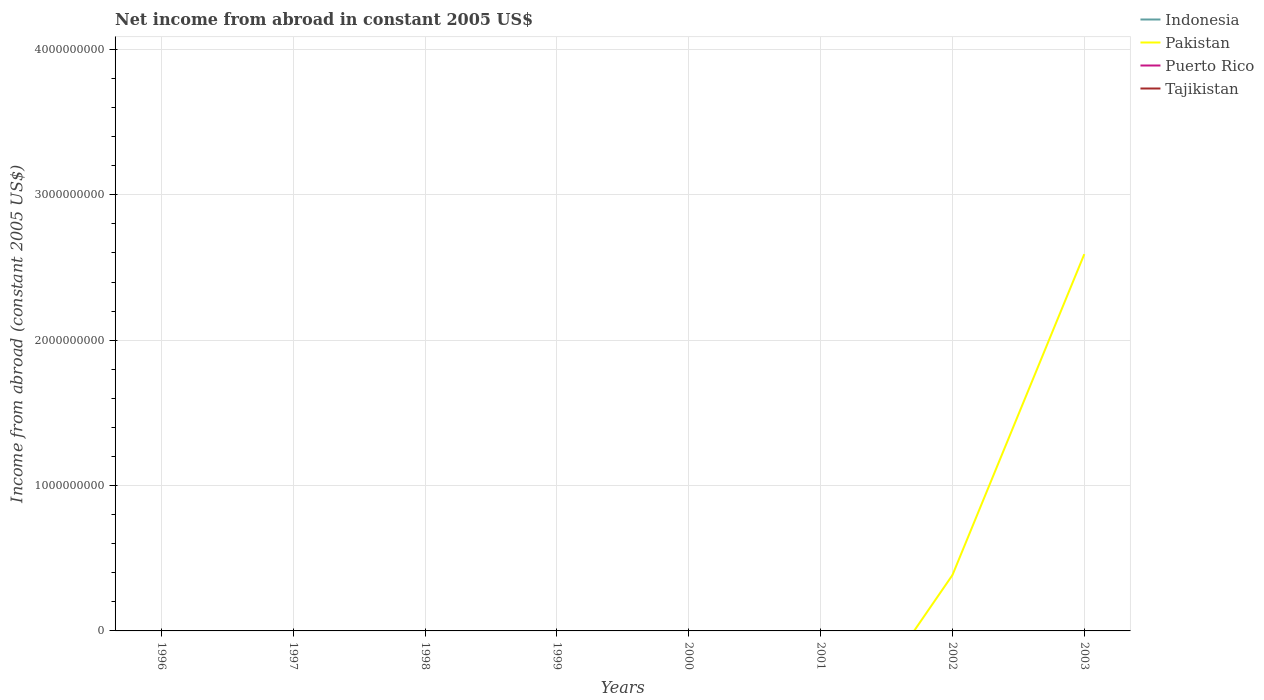Does the line corresponding to Tajikistan intersect with the line corresponding to Indonesia?
Provide a short and direct response. No. Across all years, what is the maximum net income from abroad in Puerto Rico?
Your answer should be very brief. 0. What is the difference between the highest and the second highest net income from abroad in Pakistan?
Your response must be concise. 2.59e+09. What is the difference between the highest and the lowest net income from abroad in Tajikistan?
Your answer should be compact. 0. Is the net income from abroad in Tajikistan strictly greater than the net income from abroad in Puerto Rico over the years?
Ensure brevity in your answer.  No. How many years are there in the graph?
Provide a short and direct response. 8. What is the difference between two consecutive major ticks on the Y-axis?
Offer a terse response. 1.00e+09. Does the graph contain grids?
Provide a succinct answer. Yes. Where does the legend appear in the graph?
Provide a short and direct response. Top right. How many legend labels are there?
Give a very brief answer. 4. How are the legend labels stacked?
Your answer should be compact. Vertical. What is the title of the graph?
Keep it short and to the point. Net income from abroad in constant 2005 US$. Does "Marshall Islands" appear as one of the legend labels in the graph?
Ensure brevity in your answer.  No. What is the label or title of the X-axis?
Make the answer very short. Years. What is the label or title of the Y-axis?
Offer a terse response. Income from abroad (constant 2005 US$). What is the Income from abroad (constant 2005 US$) of Pakistan in 1996?
Provide a short and direct response. 0. What is the Income from abroad (constant 2005 US$) of Tajikistan in 1996?
Offer a terse response. 0. What is the Income from abroad (constant 2005 US$) of Pakistan in 1997?
Your answer should be very brief. 0. What is the Income from abroad (constant 2005 US$) in Puerto Rico in 1997?
Your response must be concise. 0. What is the Income from abroad (constant 2005 US$) of Tajikistan in 1997?
Your response must be concise. 0. What is the Income from abroad (constant 2005 US$) of Puerto Rico in 1998?
Make the answer very short. 0. What is the Income from abroad (constant 2005 US$) of Pakistan in 1999?
Give a very brief answer. 0. What is the Income from abroad (constant 2005 US$) in Puerto Rico in 1999?
Your answer should be very brief. 0. What is the Income from abroad (constant 2005 US$) in Indonesia in 2000?
Give a very brief answer. 0. What is the Income from abroad (constant 2005 US$) of Pakistan in 2000?
Offer a terse response. 0. What is the Income from abroad (constant 2005 US$) in Tajikistan in 2000?
Provide a succinct answer. 0. What is the Income from abroad (constant 2005 US$) of Indonesia in 2002?
Your answer should be very brief. 0. What is the Income from abroad (constant 2005 US$) of Pakistan in 2002?
Provide a short and direct response. 3.84e+08. What is the Income from abroad (constant 2005 US$) of Puerto Rico in 2002?
Your answer should be compact. 0. What is the Income from abroad (constant 2005 US$) in Pakistan in 2003?
Make the answer very short. 2.59e+09. What is the Income from abroad (constant 2005 US$) of Puerto Rico in 2003?
Provide a succinct answer. 0. What is the Income from abroad (constant 2005 US$) of Tajikistan in 2003?
Provide a short and direct response. 0. Across all years, what is the maximum Income from abroad (constant 2005 US$) in Pakistan?
Provide a short and direct response. 2.59e+09. What is the total Income from abroad (constant 2005 US$) in Pakistan in the graph?
Your answer should be very brief. 2.98e+09. What is the total Income from abroad (constant 2005 US$) of Tajikistan in the graph?
Give a very brief answer. 0. What is the difference between the Income from abroad (constant 2005 US$) of Pakistan in 2002 and that in 2003?
Ensure brevity in your answer.  -2.21e+09. What is the average Income from abroad (constant 2005 US$) in Indonesia per year?
Offer a very short reply. 0. What is the average Income from abroad (constant 2005 US$) in Pakistan per year?
Make the answer very short. 3.72e+08. What is the average Income from abroad (constant 2005 US$) in Puerto Rico per year?
Your response must be concise. 0. What is the ratio of the Income from abroad (constant 2005 US$) of Pakistan in 2002 to that in 2003?
Offer a terse response. 0.15. What is the difference between the highest and the lowest Income from abroad (constant 2005 US$) of Pakistan?
Offer a very short reply. 2.59e+09. 